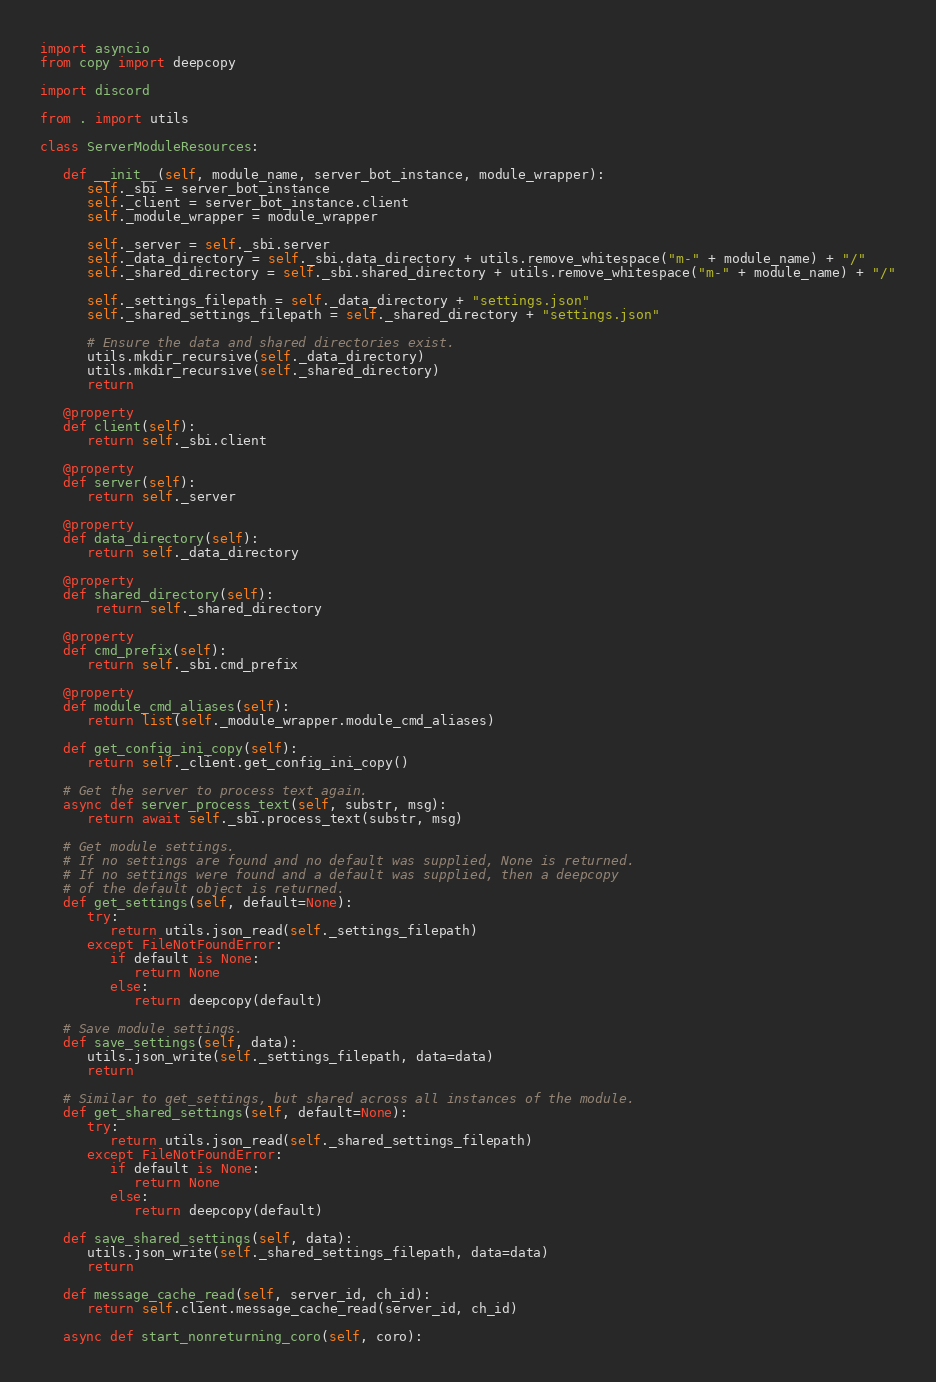Convert code to text. <code><loc_0><loc_0><loc_500><loc_500><_Python_>import asyncio
from copy import deepcopy

import discord

from . import utils

class ServerModuleResources:

   def __init__(self, module_name, server_bot_instance, module_wrapper):
      self._sbi = server_bot_instance
      self._client = server_bot_instance.client
      self._module_wrapper = module_wrapper

      self._server = self._sbi.server
      self._data_directory = self._sbi.data_directory + utils.remove_whitespace("m-" + module_name) + "/"
      self._shared_directory = self._sbi.shared_directory + utils.remove_whitespace("m-" + module_name) + "/"
      
      self._settings_filepath = self._data_directory + "settings.json"
      self._shared_settings_filepath = self._shared_directory + "settings.json"

      # Ensure the data and shared directories exist.
      utils.mkdir_recursive(self._data_directory)
      utils.mkdir_recursive(self._shared_directory)
      return

   @property
   def client(self):
      return self._sbi.client

   @property
   def server(self):
      return self._server

   @property
   def data_directory(self):
      return self._data_directory

   @property
   def shared_directory(self):
       return self._shared_directory
   
   @property
   def cmd_prefix(self):
      return self._sbi.cmd_prefix

   @property
   def module_cmd_aliases(self):
      return list(self._module_wrapper.module_cmd_aliases)

   def get_config_ini_copy(self):
      return self._client.get_config_ini_copy()
   
   # Get the server to process text again.
   async def server_process_text(self, substr, msg):
      return await self._sbi.process_text(substr, msg)

   # Get module settings.
   # If no settings are found and no default was supplied, None is returned.
   # If no settings were found and a default was supplied, then a deepcopy
   # of the default object is returned.
   def get_settings(self, default=None):
      try:
         return utils.json_read(self._settings_filepath)
      except FileNotFoundError:
         if default is None:
            return None
         else:
            return deepcopy(default)

   # Save module settings.
   def save_settings(self, data):
      utils.json_write(self._settings_filepath, data=data)
      return

   # Similar to get_settings, but shared across all instances of the module.
   def get_shared_settings(self, default=None):
      try:
         return utils.json_read(self._shared_settings_filepath)
      except FileNotFoundError:
         if default is None:
            return None
         else:
            return deepcopy(default)

   def save_shared_settings(self, data):
      utils.json_write(self._shared_settings_filepath, data=data)
      return

   def message_cache_read(self, server_id, ch_id):
      return self.client.message_cache_read(server_id, ch_id)

   async def start_nonreturning_coro(self, coro):</code> 